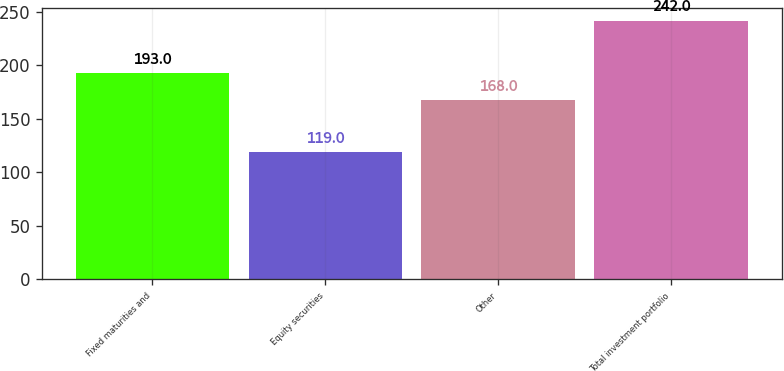<chart> <loc_0><loc_0><loc_500><loc_500><bar_chart><fcel>Fixed maturities and<fcel>Equity securities<fcel>Other<fcel>Total investment portfolio<nl><fcel>193<fcel>119<fcel>168<fcel>242<nl></chart> 